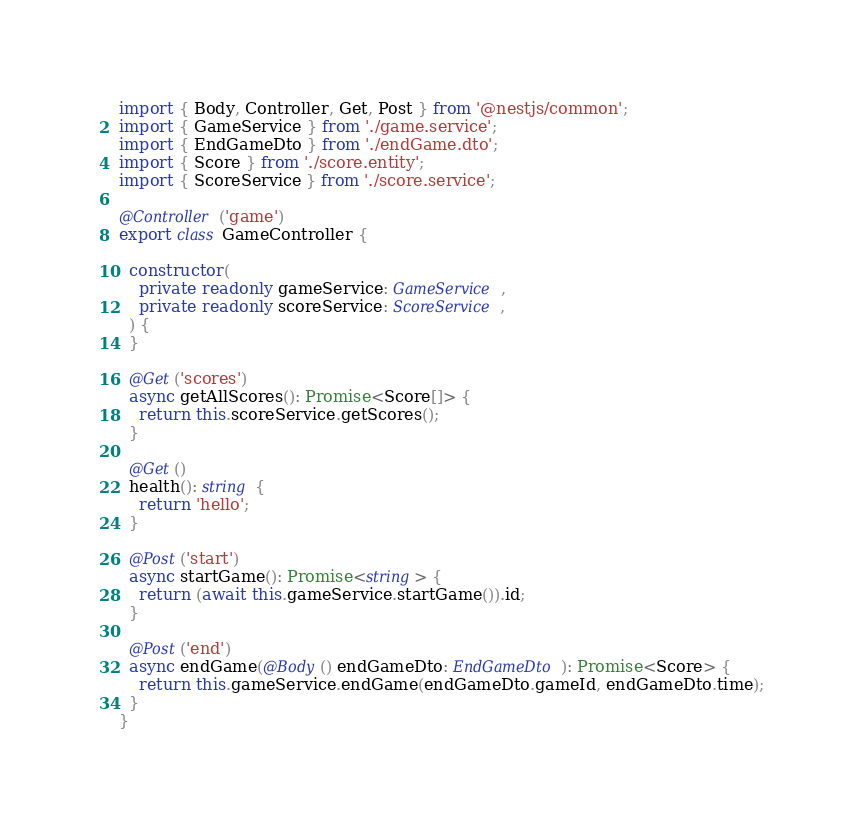<code> <loc_0><loc_0><loc_500><loc_500><_TypeScript_>import { Body, Controller, Get, Post } from '@nestjs/common';
import { GameService } from './game.service';
import { EndGameDto } from './endGame.dto';
import { Score } from './score.entity';
import { ScoreService } from './score.service';

@Controller('game')
export class GameController {

  constructor(
    private readonly gameService: GameService,
    private readonly scoreService: ScoreService,
  ) {
  }

  @Get('scores')
  async getAllScores(): Promise<Score[]> {
    return this.scoreService.getScores();
  }

  @Get()
  health(): string {
    return 'hello';
  }

  @Post('start')
  async startGame(): Promise<string> {
    return (await this.gameService.startGame()).id;
  }

  @Post('end')
  async endGame(@Body() endGameDto: EndGameDto): Promise<Score> {
    return this.gameService.endGame(endGameDto.gameId, endGameDto.time);
  }
}
</code> 